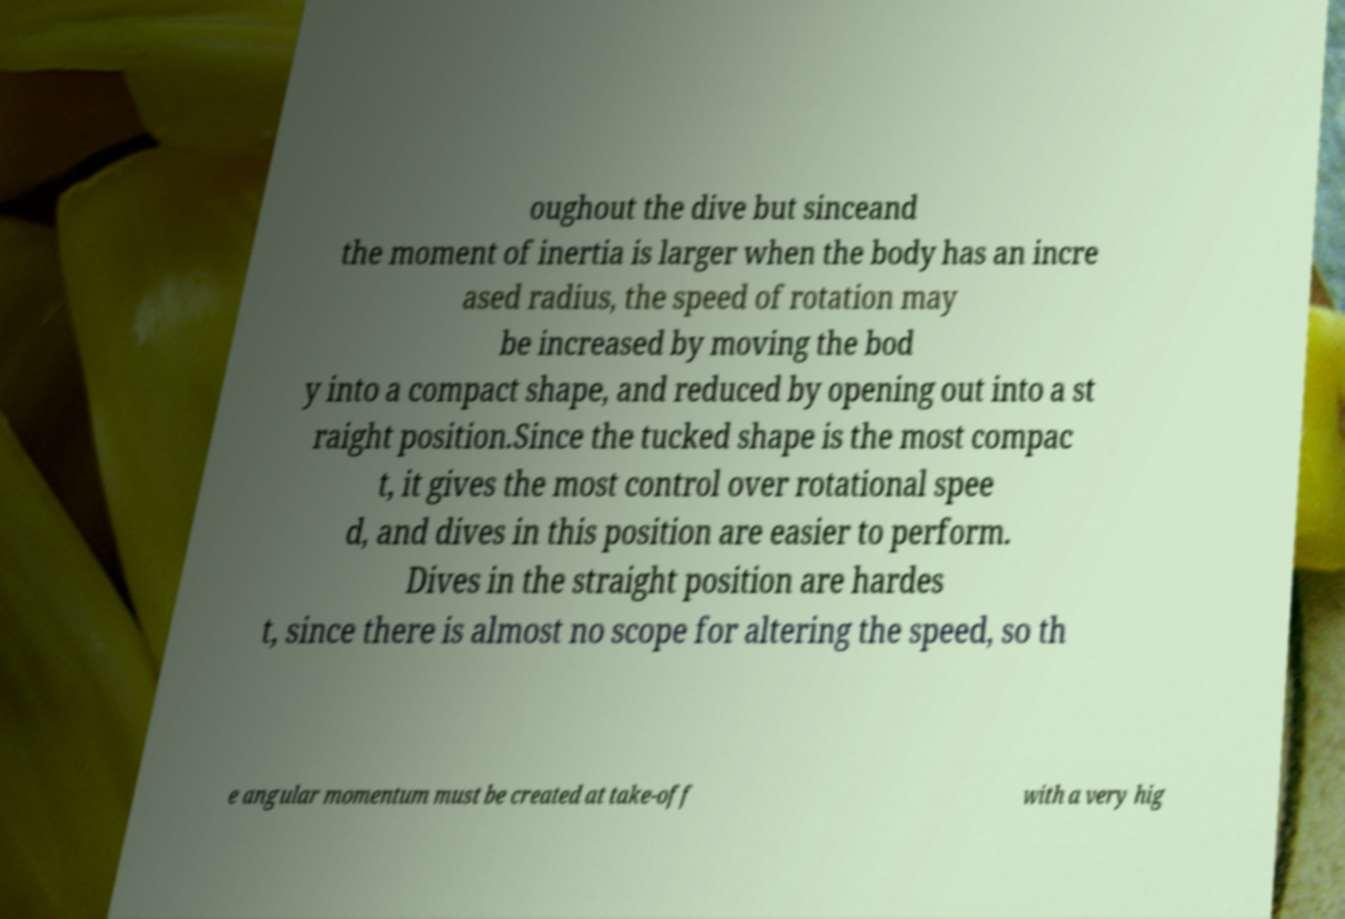Please read and relay the text visible in this image. What does it say? oughout the dive but sinceand the moment of inertia is larger when the body has an incre ased radius, the speed of rotation may be increased by moving the bod y into a compact shape, and reduced by opening out into a st raight position.Since the tucked shape is the most compac t, it gives the most control over rotational spee d, and dives in this position are easier to perform. Dives in the straight position are hardes t, since there is almost no scope for altering the speed, so th e angular momentum must be created at take-off with a very hig 